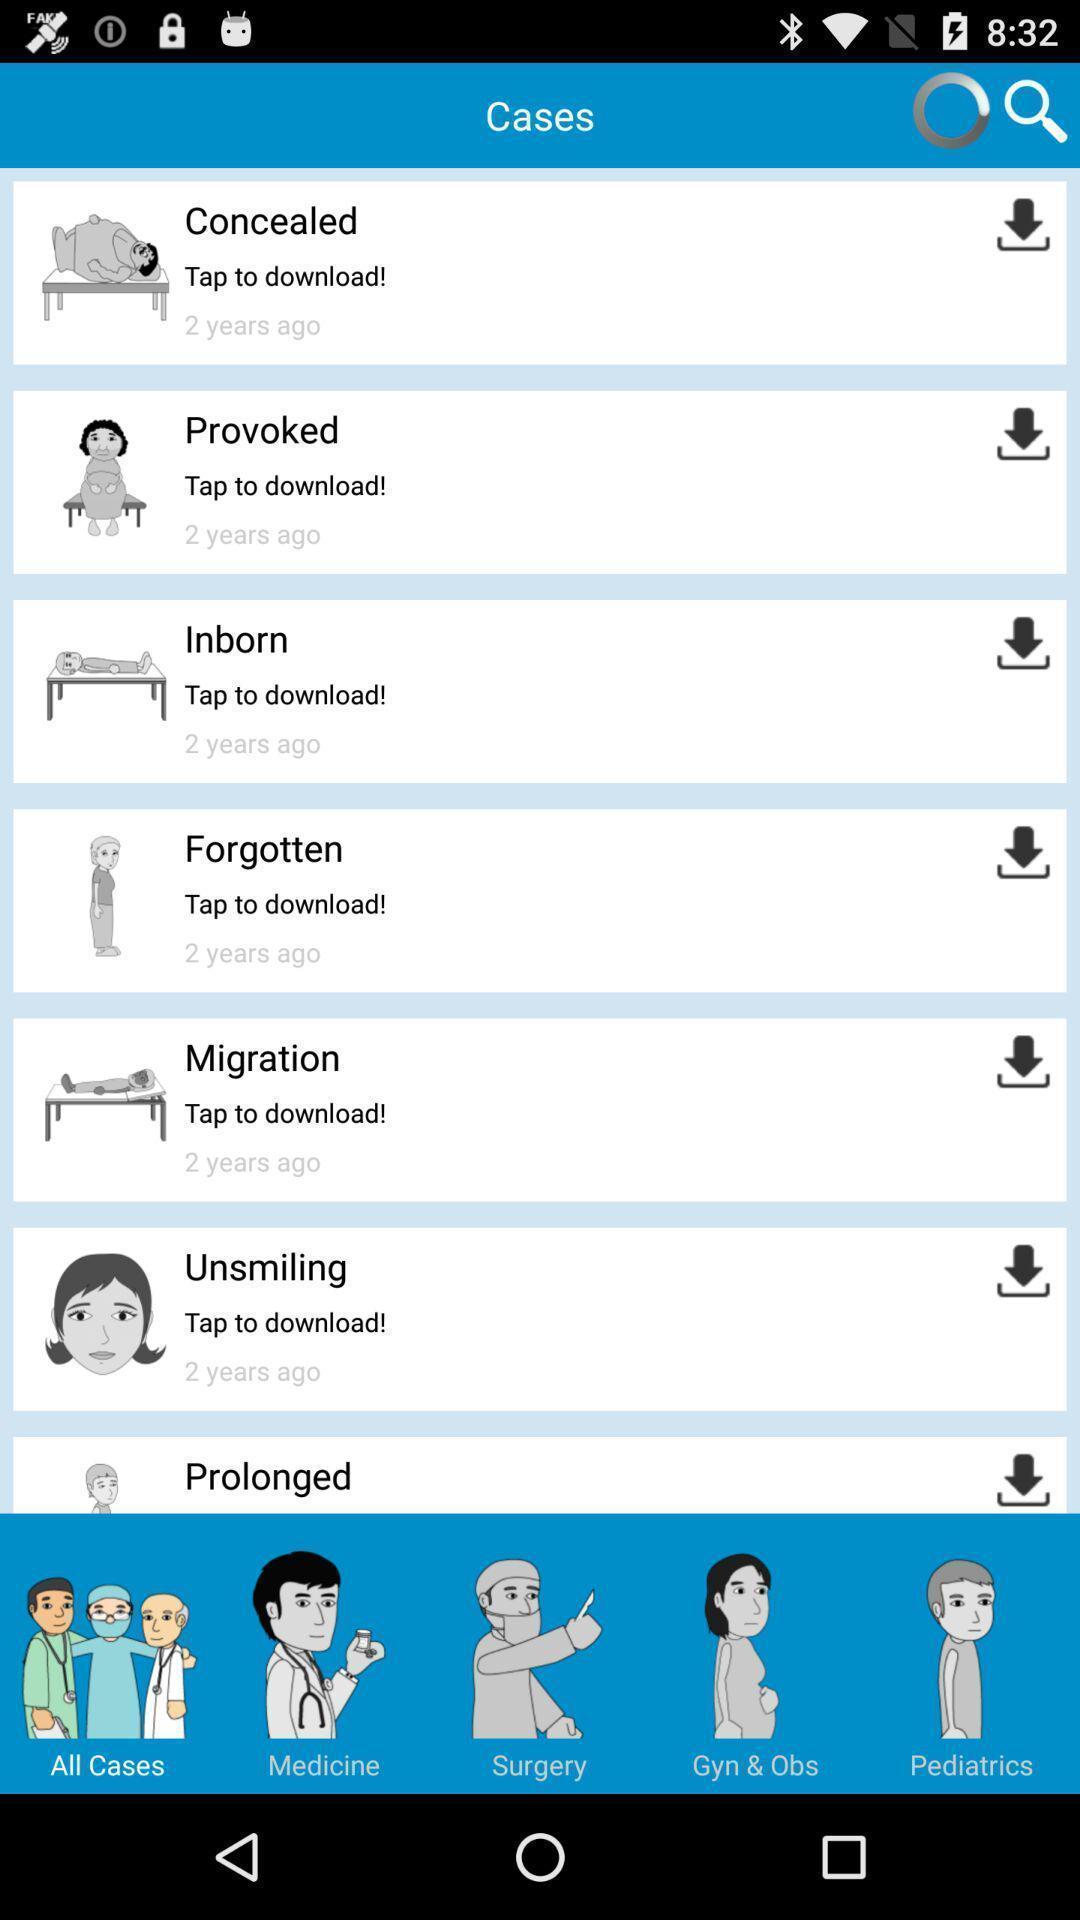Describe the key features of this screenshot. Various emotions displayed of an health care hygiene app. 